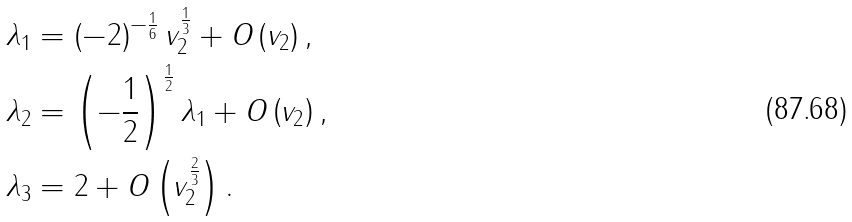<formula> <loc_0><loc_0><loc_500><loc_500>\lambda _ { 1 } & = \left ( - 2 \right ) ^ { - \frac { 1 } { 6 } } v _ { 2 } ^ { \frac { 1 } { 3 } } + O \left ( v _ { 2 } \right ) , \\ \lambda _ { 2 } & = \left ( - \frac { 1 } { 2 } \right ) ^ { \frac { 1 } { 2 } } \lambda _ { 1 } + O \left ( v _ { 2 } \right ) , \\ \lambda _ { 3 } & = 2 + O \left ( v _ { 2 } ^ { \frac { 2 } { 3 } } \right ) .</formula> 